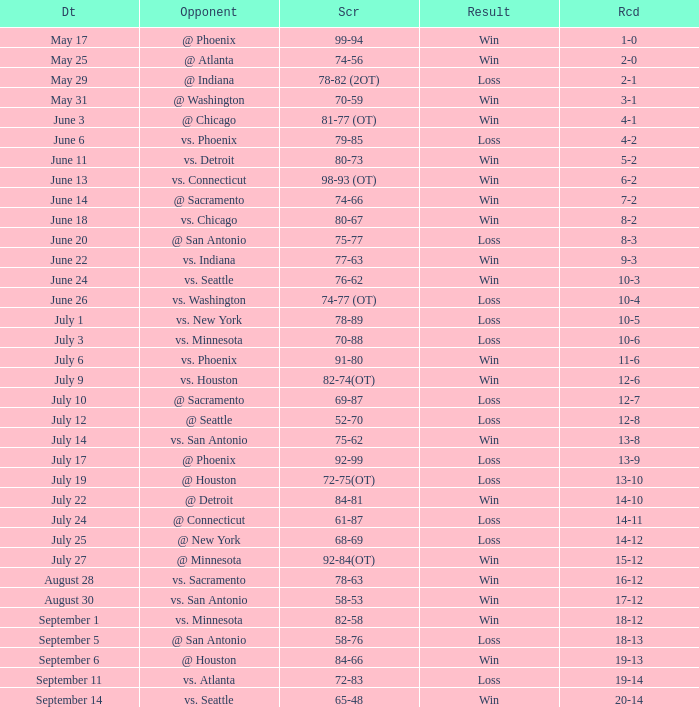What is the Record of the game with a Score of 65-48? 20-14. 